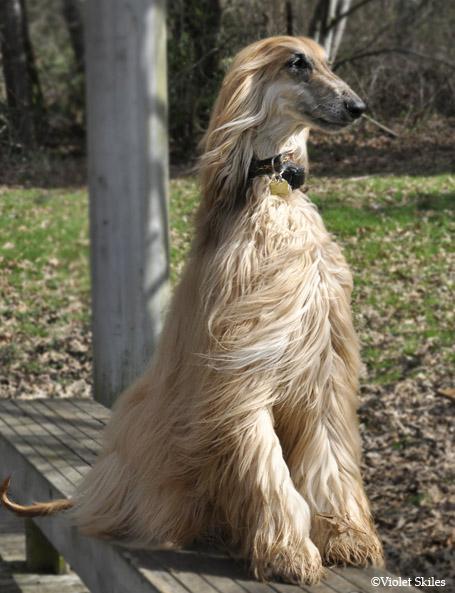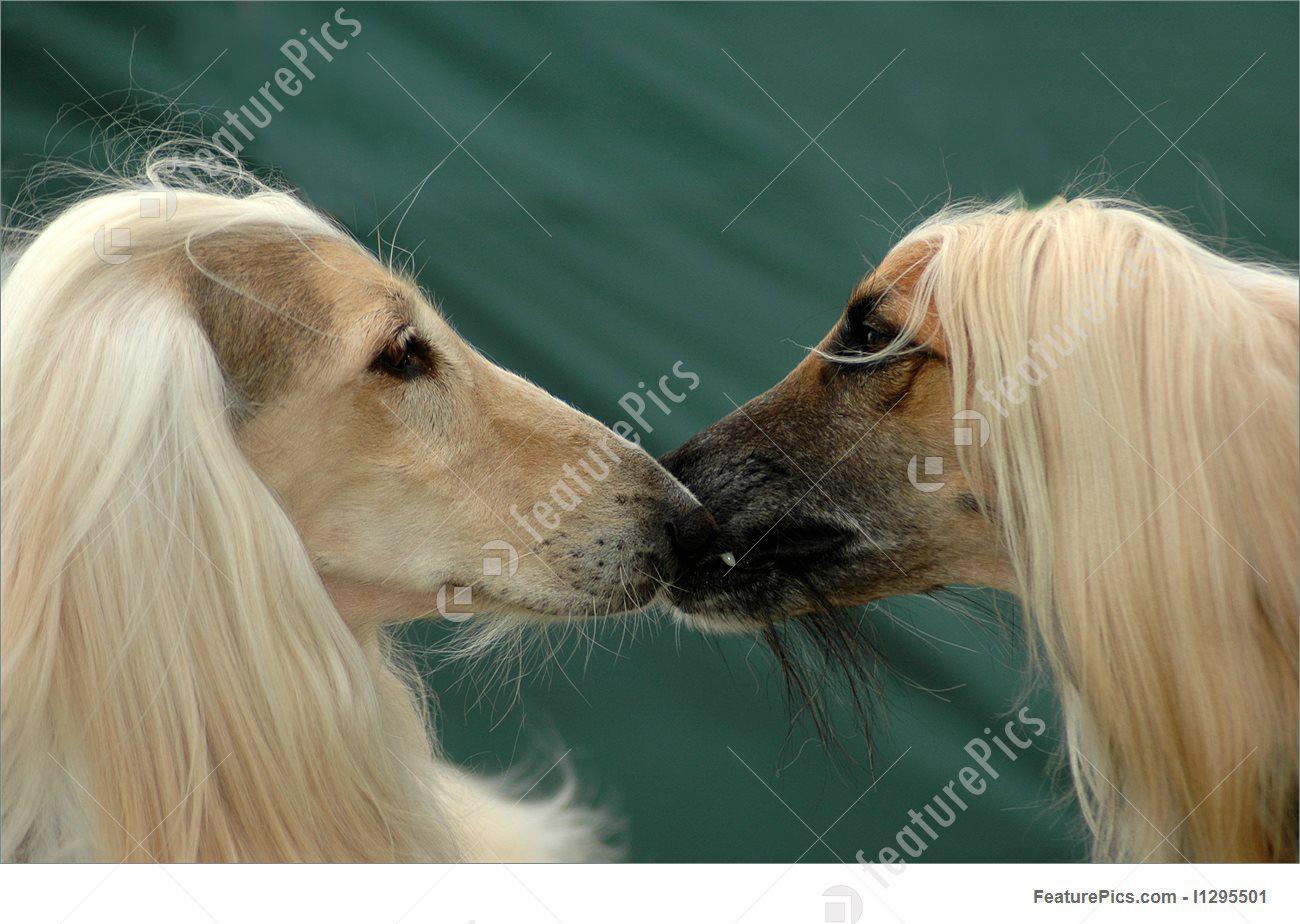The first image is the image on the left, the second image is the image on the right. For the images displayed, is the sentence "A human's arm can be seen in one of the photos." factually correct? Answer yes or no. No. The first image is the image on the left, the second image is the image on the right. Assess this claim about the two images: "There are two dogs facing each other in the image on the right.". Correct or not? Answer yes or no. Yes. 